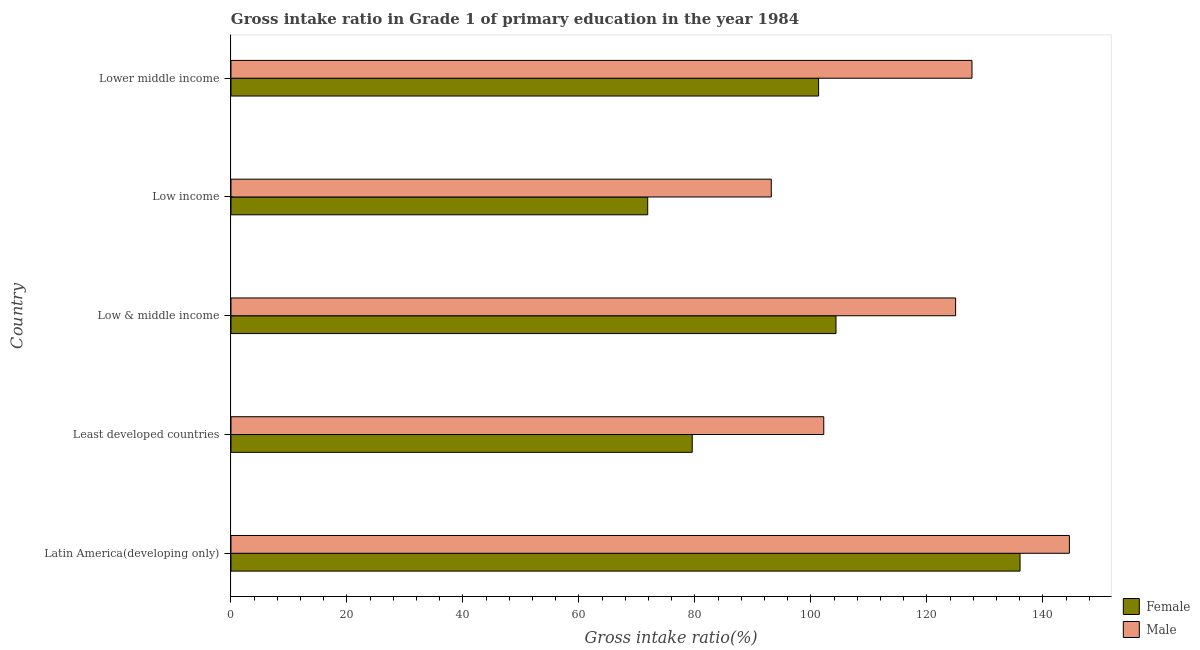Are the number of bars on each tick of the Y-axis equal?
Keep it short and to the point. Yes. How many bars are there on the 5th tick from the top?
Give a very brief answer. 2. How many bars are there on the 1st tick from the bottom?
Keep it short and to the point. 2. What is the label of the 1st group of bars from the top?
Offer a very short reply. Lower middle income. In how many cases, is the number of bars for a given country not equal to the number of legend labels?
Your answer should be compact. 0. What is the gross intake ratio(female) in Low income?
Provide a succinct answer. 71.86. Across all countries, what is the maximum gross intake ratio(female)?
Your answer should be compact. 136.07. Across all countries, what is the minimum gross intake ratio(female)?
Provide a short and direct response. 71.86. In which country was the gross intake ratio(male) maximum?
Your response must be concise. Latin America(developing only). What is the total gross intake ratio(female) in the graph?
Give a very brief answer. 493.13. What is the difference between the gross intake ratio(female) in Least developed countries and that in Low income?
Make the answer very short. 7.67. What is the difference between the gross intake ratio(male) in Low & middle income and the gross intake ratio(female) in Latin America(developing only)?
Offer a very short reply. -11.11. What is the average gross intake ratio(female) per country?
Offer a very short reply. 98.63. What is the difference between the gross intake ratio(female) and gross intake ratio(male) in Lower middle income?
Ensure brevity in your answer.  -26.45. What is the ratio of the gross intake ratio(female) in Latin America(developing only) to that in Low income?
Your answer should be compact. 1.89. Is the gross intake ratio(female) in Low income less than that in Lower middle income?
Give a very brief answer. Yes. Is the difference between the gross intake ratio(female) in Low & middle income and Low income greater than the difference between the gross intake ratio(male) in Low & middle income and Low income?
Your response must be concise. Yes. What is the difference between the highest and the second highest gross intake ratio(female)?
Give a very brief answer. 31.73. What is the difference between the highest and the lowest gross intake ratio(female)?
Your answer should be very brief. 64.2. In how many countries, is the gross intake ratio(male) greater than the average gross intake ratio(male) taken over all countries?
Offer a very short reply. 3. What does the 2nd bar from the top in Lower middle income represents?
Offer a terse response. Female. What does the 2nd bar from the bottom in Lower middle income represents?
Your answer should be compact. Male. How many bars are there?
Give a very brief answer. 10. Are all the bars in the graph horizontal?
Provide a short and direct response. Yes. What is the difference between two consecutive major ticks on the X-axis?
Offer a very short reply. 20. Does the graph contain any zero values?
Give a very brief answer. No. Does the graph contain grids?
Give a very brief answer. No. Where does the legend appear in the graph?
Your answer should be very brief. Bottom right. How many legend labels are there?
Make the answer very short. 2. What is the title of the graph?
Offer a very short reply. Gross intake ratio in Grade 1 of primary education in the year 1984. What is the label or title of the X-axis?
Offer a very short reply. Gross intake ratio(%). What is the label or title of the Y-axis?
Offer a very short reply. Country. What is the Gross intake ratio(%) of Female in Latin America(developing only)?
Your answer should be very brief. 136.07. What is the Gross intake ratio(%) in Male in Latin America(developing only)?
Offer a terse response. 144.57. What is the Gross intake ratio(%) of Female in Least developed countries?
Make the answer very short. 79.54. What is the Gross intake ratio(%) of Male in Least developed countries?
Give a very brief answer. 102.22. What is the Gross intake ratio(%) of Female in Low & middle income?
Provide a succinct answer. 104.33. What is the Gross intake ratio(%) in Male in Low & middle income?
Provide a short and direct response. 124.96. What is the Gross intake ratio(%) in Female in Low income?
Ensure brevity in your answer.  71.86. What is the Gross intake ratio(%) of Male in Low income?
Make the answer very short. 93.17. What is the Gross intake ratio(%) of Female in Lower middle income?
Ensure brevity in your answer.  101.33. What is the Gross intake ratio(%) in Male in Lower middle income?
Your answer should be compact. 127.78. Across all countries, what is the maximum Gross intake ratio(%) in Female?
Provide a short and direct response. 136.07. Across all countries, what is the maximum Gross intake ratio(%) of Male?
Give a very brief answer. 144.57. Across all countries, what is the minimum Gross intake ratio(%) of Female?
Give a very brief answer. 71.86. Across all countries, what is the minimum Gross intake ratio(%) of Male?
Your answer should be compact. 93.17. What is the total Gross intake ratio(%) in Female in the graph?
Offer a very short reply. 493.13. What is the total Gross intake ratio(%) of Male in the graph?
Provide a succinct answer. 592.7. What is the difference between the Gross intake ratio(%) of Female in Latin America(developing only) and that in Least developed countries?
Your answer should be very brief. 56.53. What is the difference between the Gross intake ratio(%) of Male in Latin America(developing only) and that in Least developed countries?
Make the answer very short. 42.35. What is the difference between the Gross intake ratio(%) of Female in Latin America(developing only) and that in Low & middle income?
Provide a short and direct response. 31.73. What is the difference between the Gross intake ratio(%) in Male in Latin America(developing only) and that in Low & middle income?
Provide a short and direct response. 19.62. What is the difference between the Gross intake ratio(%) in Female in Latin America(developing only) and that in Low income?
Provide a succinct answer. 64.2. What is the difference between the Gross intake ratio(%) in Male in Latin America(developing only) and that in Low income?
Your response must be concise. 51.4. What is the difference between the Gross intake ratio(%) of Female in Latin America(developing only) and that in Lower middle income?
Provide a short and direct response. 34.74. What is the difference between the Gross intake ratio(%) of Male in Latin America(developing only) and that in Lower middle income?
Ensure brevity in your answer.  16.8. What is the difference between the Gross intake ratio(%) of Female in Least developed countries and that in Low & middle income?
Give a very brief answer. -24.79. What is the difference between the Gross intake ratio(%) in Male in Least developed countries and that in Low & middle income?
Make the answer very short. -22.73. What is the difference between the Gross intake ratio(%) of Female in Least developed countries and that in Low income?
Provide a short and direct response. 7.67. What is the difference between the Gross intake ratio(%) of Male in Least developed countries and that in Low income?
Keep it short and to the point. 9.05. What is the difference between the Gross intake ratio(%) of Female in Least developed countries and that in Lower middle income?
Provide a succinct answer. -21.79. What is the difference between the Gross intake ratio(%) in Male in Least developed countries and that in Lower middle income?
Give a very brief answer. -25.56. What is the difference between the Gross intake ratio(%) of Female in Low & middle income and that in Low income?
Provide a short and direct response. 32.47. What is the difference between the Gross intake ratio(%) in Male in Low & middle income and that in Low income?
Keep it short and to the point. 31.79. What is the difference between the Gross intake ratio(%) of Female in Low & middle income and that in Lower middle income?
Provide a succinct answer. 3. What is the difference between the Gross intake ratio(%) in Male in Low & middle income and that in Lower middle income?
Your answer should be very brief. -2.82. What is the difference between the Gross intake ratio(%) of Female in Low income and that in Lower middle income?
Offer a very short reply. -29.47. What is the difference between the Gross intake ratio(%) of Male in Low income and that in Lower middle income?
Offer a very short reply. -34.61. What is the difference between the Gross intake ratio(%) in Female in Latin America(developing only) and the Gross intake ratio(%) in Male in Least developed countries?
Your response must be concise. 33.84. What is the difference between the Gross intake ratio(%) of Female in Latin America(developing only) and the Gross intake ratio(%) of Male in Low & middle income?
Ensure brevity in your answer.  11.11. What is the difference between the Gross intake ratio(%) in Female in Latin America(developing only) and the Gross intake ratio(%) in Male in Low income?
Your response must be concise. 42.89. What is the difference between the Gross intake ratio(%) in Female in Latin America(developing only) and the Gross intake ratio(%) in Male in Lower middle income?
Your answer should be compact. 8.29. What is the difference between the Gross intake ratio(%) in Female in Least developed countries and the Gross intake ratio(%) in Male in Low & middle income?
Offer a very short reply. -45.42. What is the difference between the Gross intake ratio(%) in Female in Least developed countries and the Gross intake ratio(%) in Male in Low income?
Ensure brevity in your answer.  -13.63. What is the difference between the Gross intake ratio(%) of Female in Least developed countries and the Gross intake ratio(%) of Male in Lower middle income?
Offer a terse response. -48.24. What is the difference between the Gross intake ratio(%) in Female in Low & middle income and the Gross intake ratio(%) in Male in Low income?
Keep it short and to the point. 11.16. What is the difference between the Gross intake ratio(%) in Female in Low & middle income and the Gross intake ratio(%) in Male in Lower middle income?
Give a very brief answer. -23.45. What is the difference between the Gross intake ratio(%) of Female in Low income and the Gross intake ratio(%) of Male in Lower middle income?
Offer a terse response. -55.91. What is the average Gross intake ratio(%) of Female per country?
Provide a succinct answer. 98.63. What is the average Gross intake ratio(%) of Male per country?
Ensure brevity in your answer.  118.54. What is the difference between the Gross intake ratio(%) of Female and Gross intake ratio(%) of Male in Latin America(developing only)?
Offer a terse response. -8.51. What is the difference between the Gross intake ratio(%) in Female and Gross intake ratio(%) in Male in Least developed countries?
Provide a short and direct response. -22.68. What is the difference between the Gross intake ratio(%) of Female and Gross intake ratio(%) of Male in Low & middle income?
Give a very brief answer. -20.63. What is the difference between the Gross intake ratio(%) in Female and Gross intake ratio(%) in Male in Low income?
Offer a terse response. -21.31. What is the difference between the Gross intake ratio(%) in Female and Gross intake ratio(%) in Male in Lower middle income?
Make the answer very short. -26.45. What is the ratio of the Gross intake ratio(%) in Female in Latin America(developing only) to that in Least developed countries?
Provide a succinct answer. 1.71. What is the ratio of the Gross intake ratio(%) of Male in Latin America(developing only) to that in Least developed countries?
Your response must be concise. 1.41. What is the ratio of the Gross intake ratio(%) in Female in Latin America(developing only) to that in Low & middle income?
Your response must be concise. 1.3. What is the ratio of the Gross intake ratio(%) of Male in Latin America(developing only) to that in Low & middle income?
Keep it short and to the point. 1.16. What is the ratio of the Gross intake ratio(%) in Female in Latin America(developing only) to that in Low income?
Offer a very short reply. 1.89. What is the ratio of the Gross intake ratio(%) of Male in Latin America(developing only) to that in Low income?
Provide a succinct answer. 1.55. What is the ratio of the Gross intake ratio(%) of Female in Latin America(developing only) to that in Lower middle income?
Give a very brief answer. 1.34. What is the ratio of the Gross intake ratio(%) in Male in Latin America(developing only) to that in Lower middle income?
Keep it short and to the point. 1.13. What is the ratio of the Gross intake ratio(%) of Female in Least developed countries to that in Low & middle income?
Make the answer very short. 0.76. What is the ratio of the Gross intake ratio(%) in Male in Least developed countries to that in Low & middle income?
Offer a very short reply. 0.82. What is the ratio of the Gross intake ratio(%) of Female in Least developed countries to that in Low income?
Provide a succinct answer. 1.11. What is the ratio of the Gross intake ratio(%) of Male in Least developed countries to that in Low income?
Offer a terse response. 1.1. What is the ratio of the Gross intake ratio(%) of Female in Least developed countries to that in Lower middle income?
Your response must be concise. 0.78. What is the ratio of the Gross intake ratio(%) of Male in Least developed countries to that in Lower middle income?
Your response must be concise. 0.8. What is the ratio of the Gross intake ratio(%) in Female in Low & middle income to that in Low income?
Make the answer very short. 1.45. What is the ratio of the Gross intake ratio(%) of Male in Low & middle income to that in Low income?
Offer a terse response. 1.34. What is the ratio of the Gross intake ratio(%) in Female in Low & middle income to that in Lower middle income?
Give a very brief answer. 1.03. What is the ratio of the Gross intake ratio(%) in Male in Low & middle income to that in Lower middle income?
Your response must be concise. 0.98. What is the ratio of the Gross intake ratio(%) of Female in Low income to that in Lower middle income?
Ensure brevity in your answer.  0.71. What is the ratio of the Gross intake ratio(%) of Male in Low income to that in Lower middle income?
Provide a short and direct response. 0.73. What is the difference between the highest and the second highest Gross intake ratio(%) of Female?
Ensure brevity in your answer.  31.73. What is the difference between the highest and the second highest Gross intake ratio(%) in Male?
Provide a short and direct response. 16.8. What is the difference between the highest and the lowest Gross intake ratio(%) of Female?
Your response must be concise. 64.2. What is the difference between the highest and the lowest Gross intake ratio(%) in Male?
Keep it short and to the point. 51.4. 